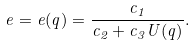<formula> <loc_0><loc_0><loc_500><loc_500>e = e ( q ) = \frac { c _ { 1 } } { c _ { 2 } + c _ { 3 } U ( q ) } .</formula> 